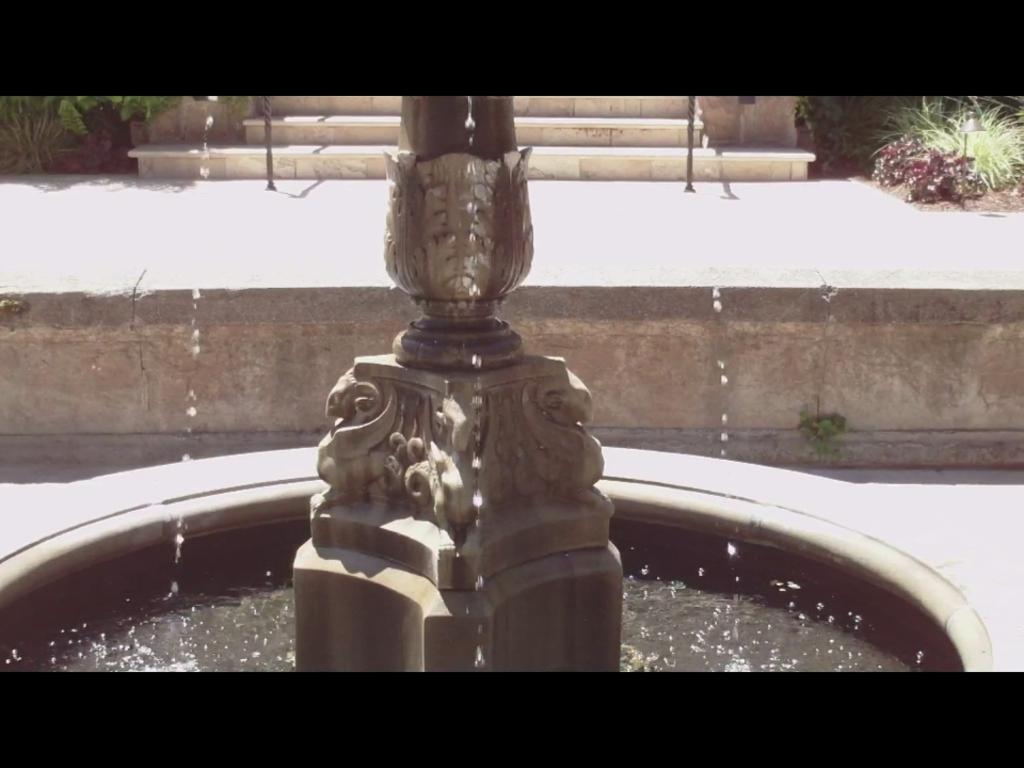How would you summarize this image in a sentence or two? In the background we can see stairs and plants. Here we can see water and a pedestal. 